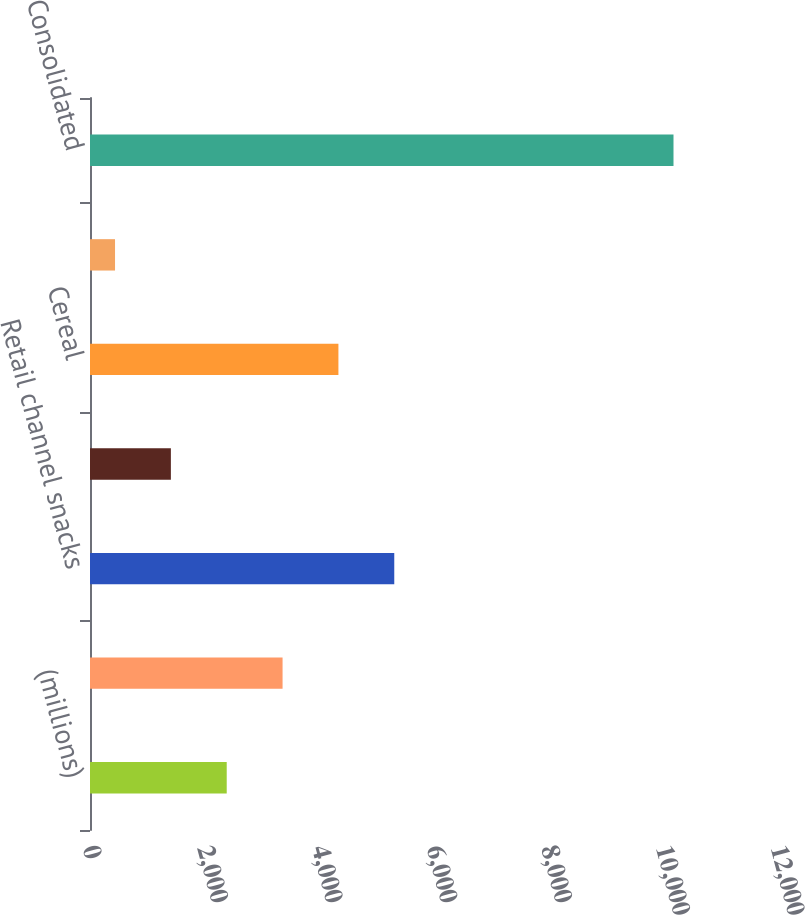Convert chart. <chart><loc_0><loc_0><loc_500><loc_500><bar_chart><fcel>(millions)<fcel>Retail channel cereal<fcel>Retail channel snacks<fcel>Other<fcel>Cereal<fcel>Convenience foods<fcel>Consolidated<nl><fcel>2384.72<fcel>3358.78<fcel>5306.9<fcel>1410.66<fcel>4332.84<fcel>436.6<fcel>10177.2<nl></chart> 